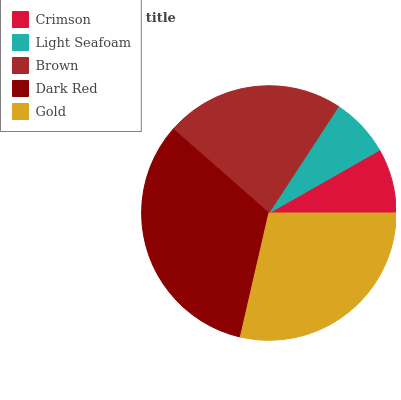Is Light Seafoam the minimum?
Answer yes or no. Yes. Is Dark Red the maximum?
Answer yes or no. Yes. Is Brown the minimum?
Answer yes or no. No. Is Brown the maximum?
Answer yes or no. No. Is Brown greater than Light Seafoam?
Answer yes or no. Yes. Is Light Seafoam less than Brown?
Answer yes or no. Yes. Is Light Seafoam greater than Brown?
Answer yes or no. No. Is Brown less than Light Seafoam?
Answer yes or no. No. Is Brown the high median?
Answer yes or no. Yes. Is Brown the low median?
Answer yes or no. Yes. Is Dark Red the high median?
Answer yes or no. No. Is Light Seafoam the low median?
Answer yes or no. No. 